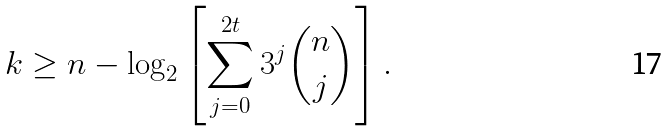Convert formula to latex. <formula><loc_0><loc_0><loc_500><loc_500>k \geq n - \log _ { 2 } \left [ \sum _ { j = 0 } ^ { 2 t } 3 ^ { j } \binom { n } { j } \right ] .</formula> 